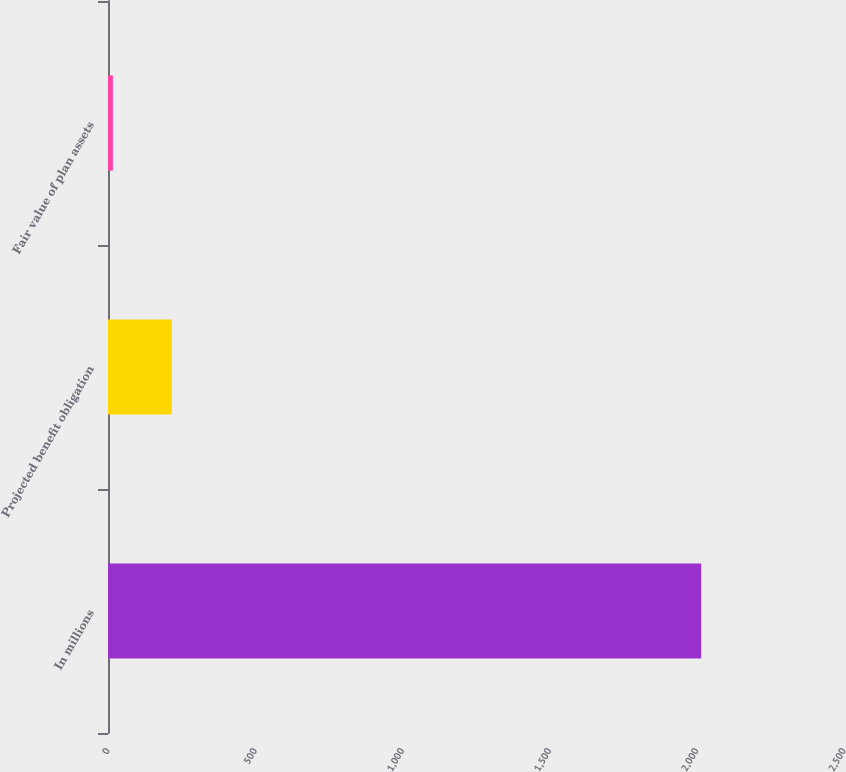<chart> <loc_0><loc_0><loc_500><loc_500><bar_chart><fcel>In millions<fcel>Projected benefit obligation<fcel>Fair value of plan assets<nl><fcel>2015<fcel>216.44<fcel>16.6<nl></chart> 